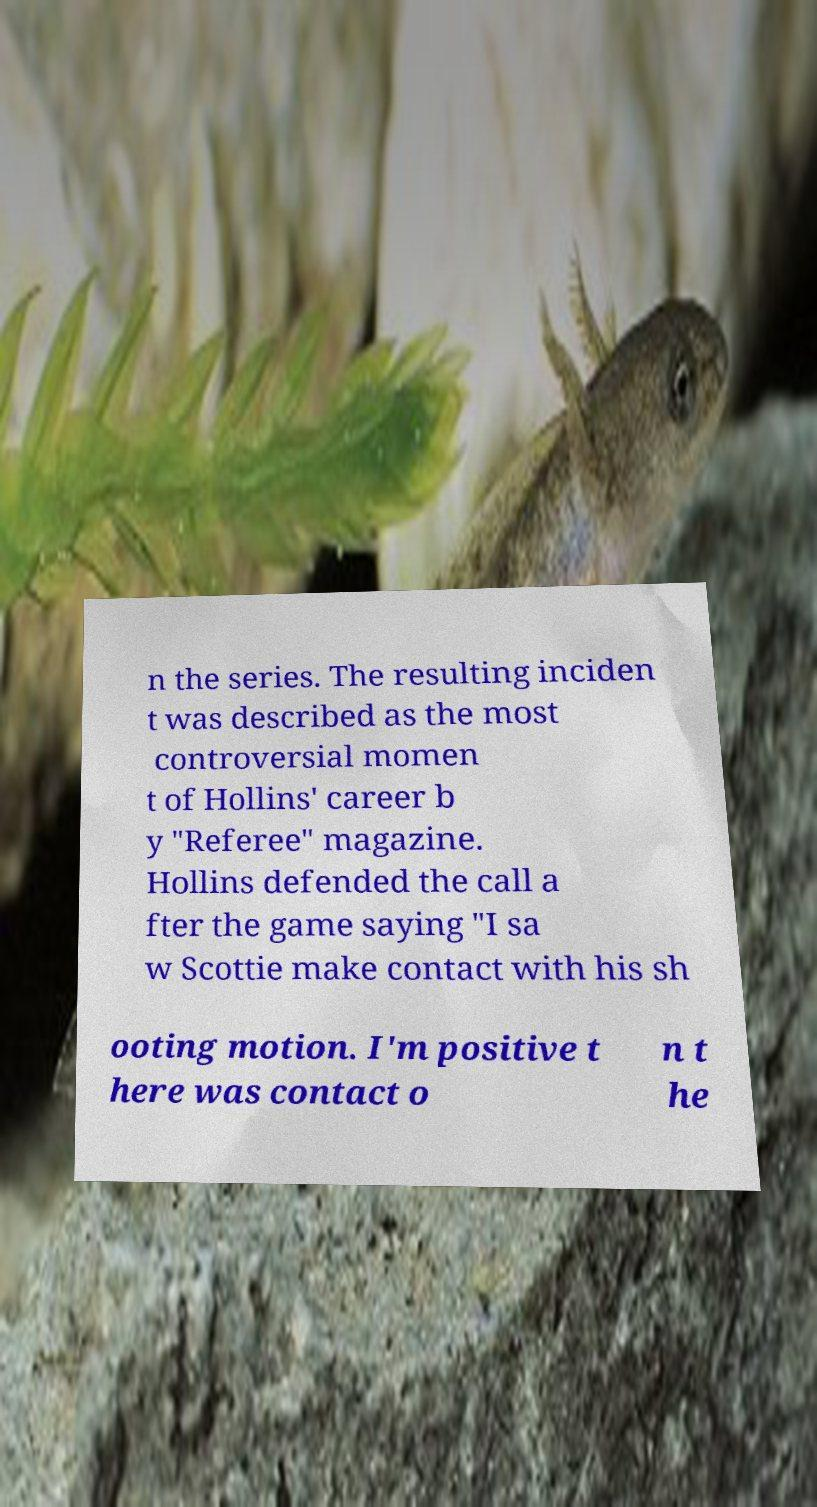I need the written content from this picture converted into text. Can you do that? n the series. The resulting inciden t was described as the most controversial momen t of Hollins' career b y "Referee" magazine. Hollins defended the call a fter the game saying "I sa w Scottie make contact with his sh ooting motion. I'm positive t here was contact o n t he 